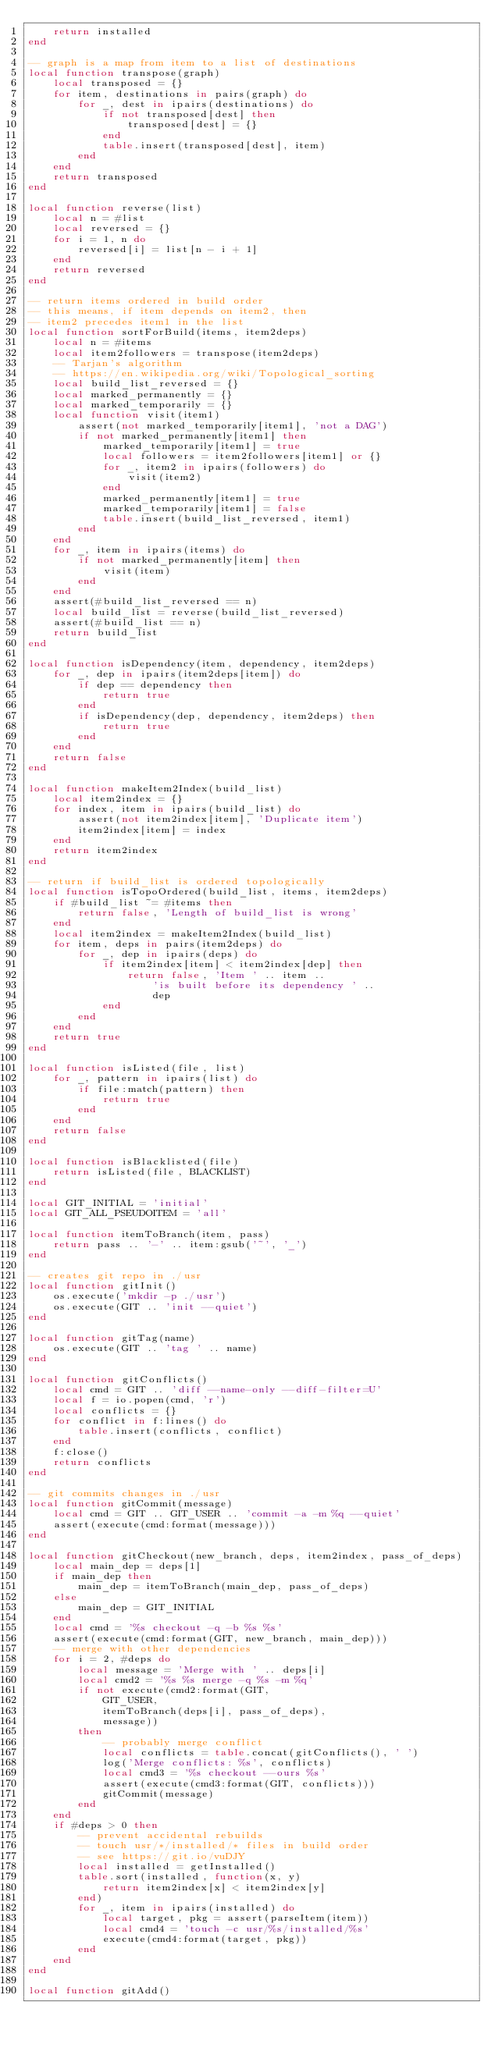<code> <loc_0><loc_0><loc_500><loc_500><_Lua_>    return installed
end

-- graph is a map from item to a list of destinations
local function transpose(graph)
    local transposed = {}
    for item, destinations in pairs(graph) do
        for _, dest in ipairs(destinations) do
            if not transposed[dest] then
                transposed[dest] = {}
            end
            table.insert(transposed[dest], item)
        end
    end
    return transposed
end

local function reverse(list)
    local n = #list
    local reversed = {}
    for i = 1, n do
        reversed[i] = list[n - i + 1]
    end
    return reversed
end

-- return items ordered in build order
-- this means, if item depends on item2, then
-- item2 precedes item1 in the list
local function sortForBuild(items, item2deps)
    local n = #items
    local item2followers = transpose(item2deps)
    -- Tarjan's algorithm
    -- https://en.wikipedia.org/wiki/Topological_sorting
    local build_list_reversed = {}
    local marked_permanently = {}
    local marked_temporarily = {}
    local function visit(item1)
        assert(not marked_temporarily[item1], 'not a DAG')
        if not marked_permanently[item1] then
            marked_temporarily[item1] = true
            local followers = item2followers[item1] or {}
            for _, item2 in ipairs(followers) do
                visit(item2)
            end
            marked_permanently[item1] = true
            marked_temporarily[item1] = false
            table.insert(build_list_reversed, item1)
        end
    end
    for _, item in ipairs(items) do
        if not marked_permanently[item] then
            visit(item)
        end
    end
    assert(#build_list_reversed == n)
    local build_list = reverse(build_list_reversed)
    assert(#build_list == n)
    return build_list
end

local function isDependency(item, dependency, item2deps)
    for _, dep in ipairs(item2deps[item]) do
        if dep == dependency then
            return true
        end
        if isDependency(dep, dependency, item2deps) then
            return true
        end
    end
    return false
end

local function makeItem2Index(build_list)
    local item2index = {}
    for index, item in ipairs(build_list) do
        assert(not item2index[item], 'Duplicate item')
        item2index[item] = index
    end
    return item2index
end

-- return if build_list is ordered topologically
local function isTopoOrdered(build_list, items, item2deps)
    if #build_list ~= #items then
        return false, 'Length of build_list is wrong'
    end
    local item2index = makeItem2Index(build_list)
    for item, deps in pairs(item2deps) do
        for _, dep in ipairs(deps) do
            if item2index[item] < item2index[dep] then
                return false, 'Item ' .. item ..
                    'is built before its dependency ' ..
                    dep
            end
        end
    end
    return true
end

local function isListed(file, list)
    for _, pattern in ipairs(list) do
        if file:match(pattern) then
            return true
        end
    end
    return false
end

local function isBlacklisted(file)
    return isListed(file, BLACKLIST)
end

local GIT_INITIAL = 'initial'
local GIT_ALL_PSEUDOITEM = 'all'

local function itemToBranch(item, pass)
    return pass .. '-' .. item:gsub('~', '_')
end

-- creates git repo in ./usr
local function gitInit()
    os.execute('mkdir -p ./usr')
    os.execute(GIT .. 'init --quiet')
end

local function gitTag(name)
    os.execute(GIT .. 'tag ' .. name)
end

local function gitConflicts()
    local cmd = GIT .. 'diff --name-only --diff-filter=U'
    local f = io.popen(cmd, 'r')
    local conflicts = {}
    for conflict in f:lines() do
        table.insert(conflicts, conflict)
    end
    f:close()
    return conflicts
end

-- git commits changes in ./usr
local function gitCommit(message)
    local cmd = GIT .. GIT_USER .. 'commit -a -m %q --quiet'
    assert(execute(cmd:format(message)))
end

local function gitCheckout(new_branch, deps, item2index, pass_of_deps)
    local main_dep = deps[1]
    if main_dep then
        main_dep = itemToBranch(main_dep, pass_of_deps)
    else
        main_dep = GIT_INITIAL
    end
    local cmd = '%s checkout -q -b %s %s'
    assert(execute(cmd:format(GIT, new_branch, main_dep)))
    -- merge with other dependencies
    for i = 2, #deps do
        local message = 'Merge with ' .. deps[i]
        local cmd2 = '%s %s merge -q %s -m %q'
        if not execute(cmd2:format(GIT,
            GIT_USER,
            itemToBranch(deps[i], pass_of_deps),
            message))
        then
            -- probably merge conflict
            local conflicts = table.concat(gitConflicts(), ' ')
            log('Merge conflicts: %s', conflicts)
            local cmd3 = '%s checkout --ours %s'
            assert(execute(cmd3:format(GIT, conflicts)))
            gitCommit(message)
        end
    end
    if #deps > 0 then
        -- prevent accidental rebuilds
        -- touch usr/*/installed/* files in build order
        -- see https://git.io/vuDJY
        local installed = getInstalled()
        table.sort(installed, function(x, y)
            return item2index[x] < item2index[y]
        end)
        for _, item in ipairs(installed) do
            local target, pkg = assert(parseItem(item))
            local cmd4 = 'touch -c usr/%s/installed/%s'
            execute(cmd4:format(target, pkg))
        end
    end
end

local function gitAdd()</code> 